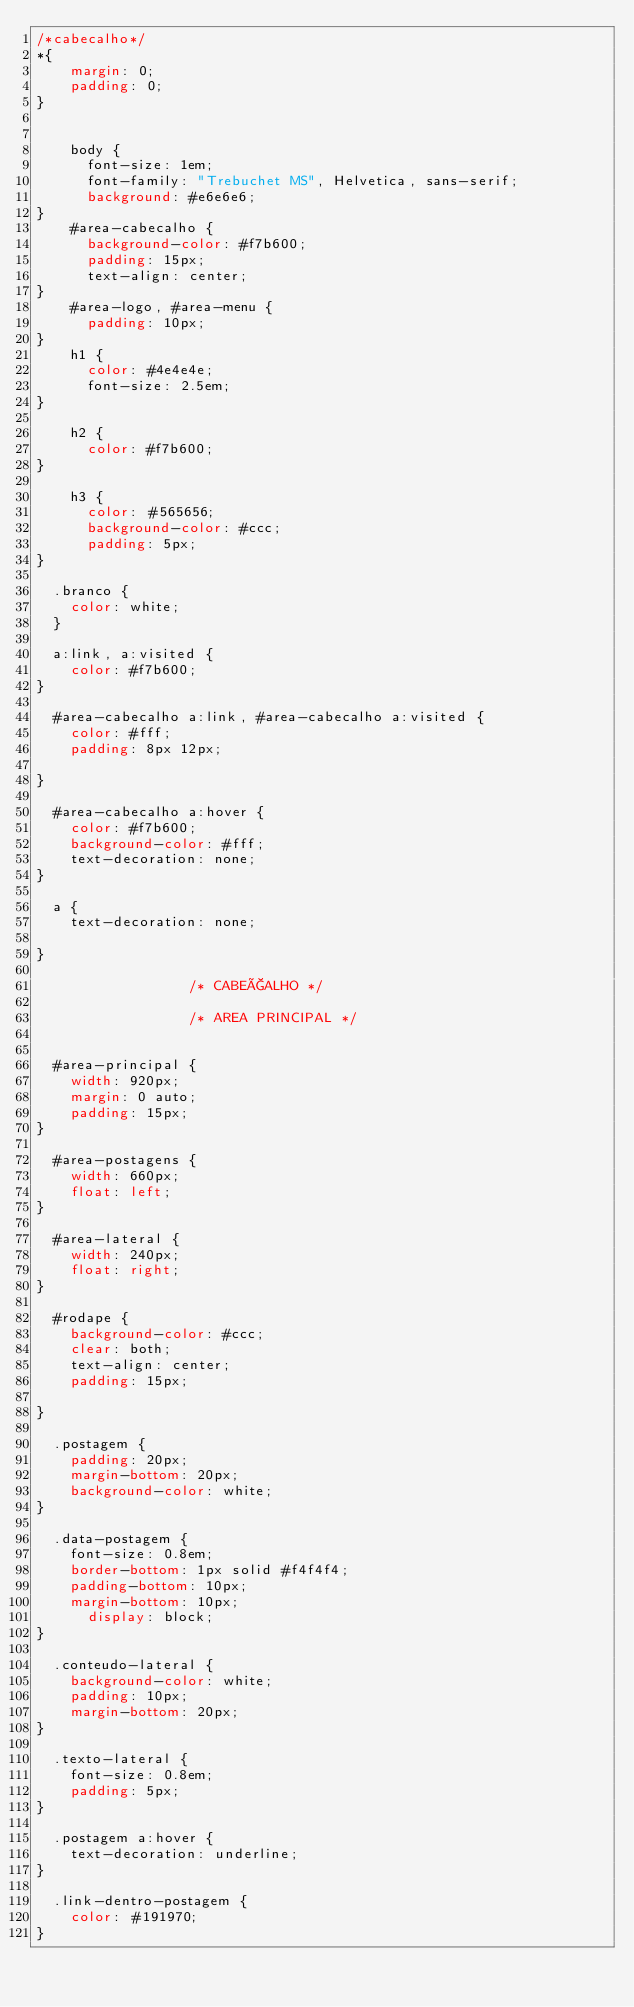Convert code to text. <code><loc_0><loc_0><loc_500><loc_500><_CSS_>/*cabecalho*/
*{
    margin: 0;
    padding: 0;
}


    body {
	    font-size: 1em;
	    font-family: "Trebuchet MS", Helvetica, sans-serif;
	    background: #e6e6e6;
}    
    #area-cabecalho {
	    background-color: #f7b600;
	    padding: 15px;
	    text-align: center;
}
    #area-logo, #area-menu {
	    padding: 10px;
}
    h1 {
	    color: #4e4e4e;
	    font-size: 2.5em;
}

    h2 {
	    color: #f7b600;
}

    h3 {
	    color: #565656;
	    background-color: #ccc;
	    padding: 5px;
}

	.branco {
		color: white;
	}
	
	a:link, a:visited {
		color: #f7b600;
}

	#area-cabecalho a:link, #area-cabecalho a:visited {
		color: #fff;
		padding: 8px 12px;

}

	#area-cabecalho a:hover {
		color: #f7b600;
		background-color: #fff;
		text-decoration: none;
}

	a {
		text-decoration: none;

}

									/* CABEÇALHO */

									/* AREA PRINCIPAL */


	#area-principal {
		width: 920px;
		margin: 0 auto;
		padding: 15px;
}

	#area-postagens {
		width: 660px;
		float: left;
}

	#area-lateral {
		width: 240px;
		float: right;
}

	#rodape {
		background-color: #ccc;
		clear: both;
		text-align: center;
		padding: 15px;

}

	.postagem {
		padding: 20px;
		margin-bottom: 20px;
		background-color: white; 
}

	.data-postagem {
		font-size: 0.8em;
		border-bottom: 1px solid #f4f4f4;
		padding-bottom: 10px;
		margin-bottom: 10px;
			display: block; 
}

	.conteudo-lateral {
		background-color: white;
		padding: 10px;
		margin-bottom: 20px;
}

	.texto-lateral {
		font-size: 0.8em;
		padding: 5px;
}

	.postagem a:hover {
		text-decoration: underline;
}

	.link-dentro-postagem {
		color: #191970;
}</code> 